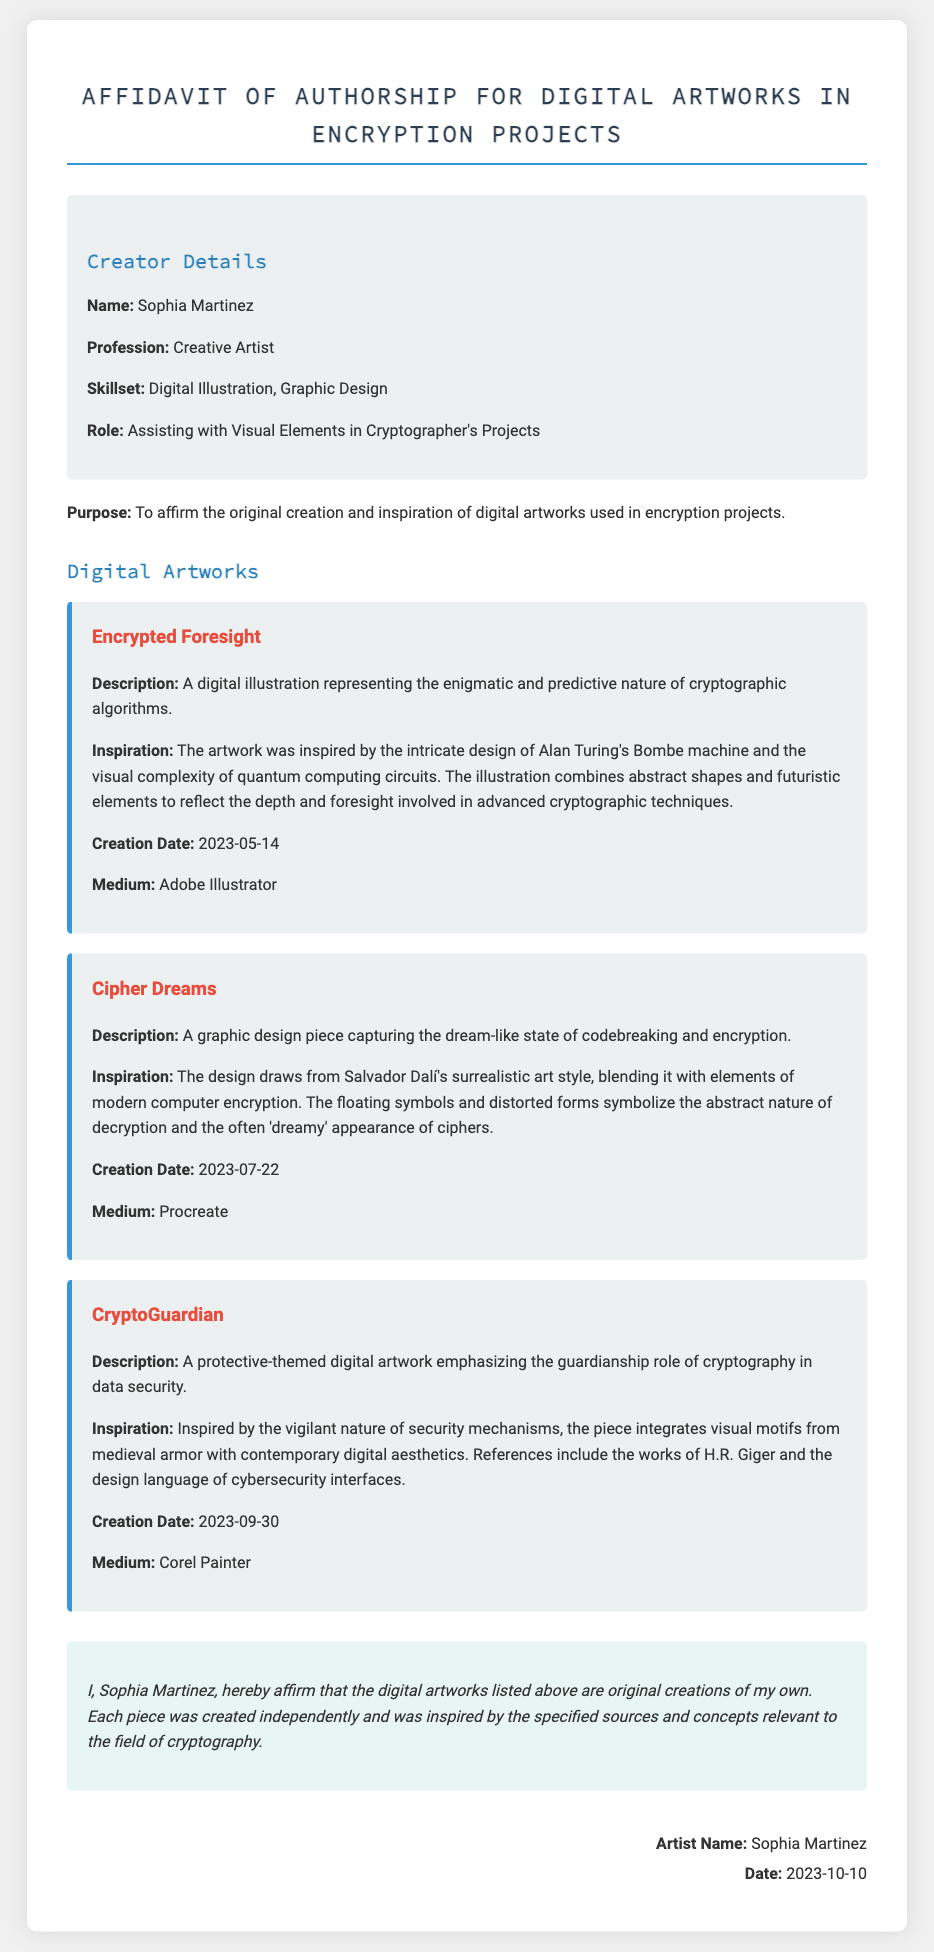What is the artist's name? The artist's name is listed in the creator details section of the document.
Answer: Sophia Martinez What is the creation date of "Encrypted Foresight"? The creation date is specified in the artwork section for "Encrypted Foresight."
Answer: 2023-05-14 What medium was used for "Cipher Dreams"? The medium is mentioned in the specific artwork section for "Cipher Dreams."
Answer: Procreate Which artwork draws inspiration from Salvador Dalí's art style? The inspiration for each artwork is provided, pointing out the sources of creativity.
Answer: Cipher Dreams How many digital artworks are listed in the document? The document provides a count of the individual artworks included.
Answer: Three What profession does Sophia Martinez hold? The profession is explicitly stated in the creator details of the document.
Answer: Creative Artist What is the purpose of the affidavit? The purpose is described at the beginning of the document and relates to the artworks presented.
Answer: To affirm the original creation and inspiration What visual motif is referenced in "CryptoGuardian"? The visual motifs are outlined in the description of "CryptoGuardian."
Answer: Medieval armor What date was the affidavit signed? The signing date is included at the end of the document, noting when the affidavit was completed.
Answer: 2023-10-10 